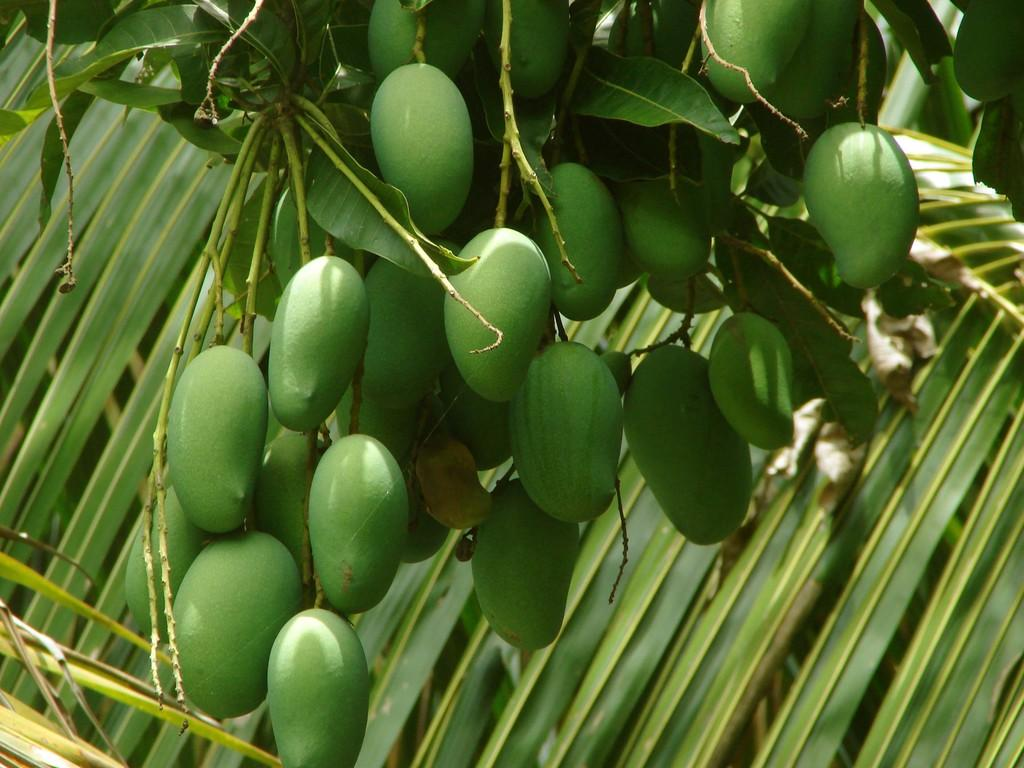What type of fruit can be seen hanging from the tree in the image? There are mangoes hanging from a tree in the image. What can be seen in the background of the image? There are coconut leaves visible in the background of the image. Can you tell me how many horses are grazing under the mango tree in the image? There are no horses present in the image; it only features mangoes hanging from a tree and coconut leaves in the background. 